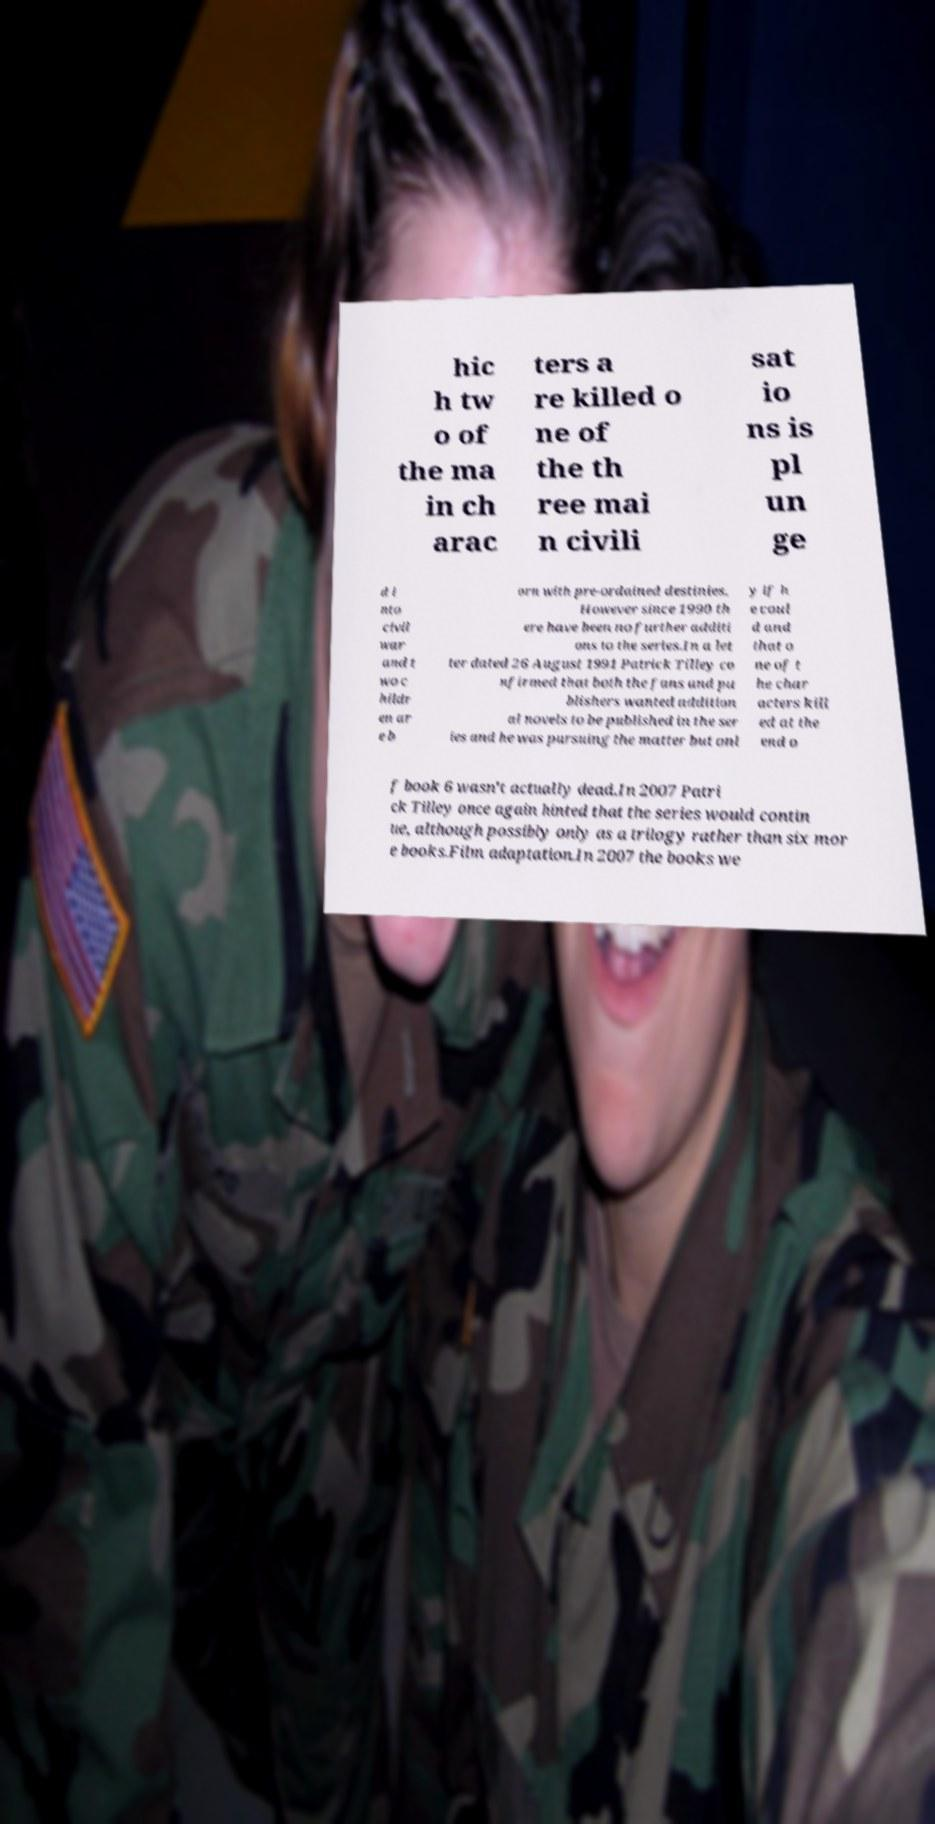Please identify and transcribe the text found in this image. hic h tw o of the ma in ch arac ters a re killed o ne of the th ree mai n civili sat io ns is pl un ge d i nto civil war and t wo c hildr en ar e b orn with pre-ordained destinies. However since 1990 th ere have been no further additi ons to the series.In a let ter dated 26 August 1991 Patrick Tilley co nfirmed that both the fans and pu blishers wanted addition al novels to be published in the ser ies and he was pursuing the matter but onl y if h e coul d and that o ne of t he char acters kill ed at the end o f book 6 wasn't actually dead.In 2007 Patri ck Tilley once again hinted that the series would contin ue, although possibly only as a trilogy rather than six mor e books.Film adaptation.In 2007 the books we 